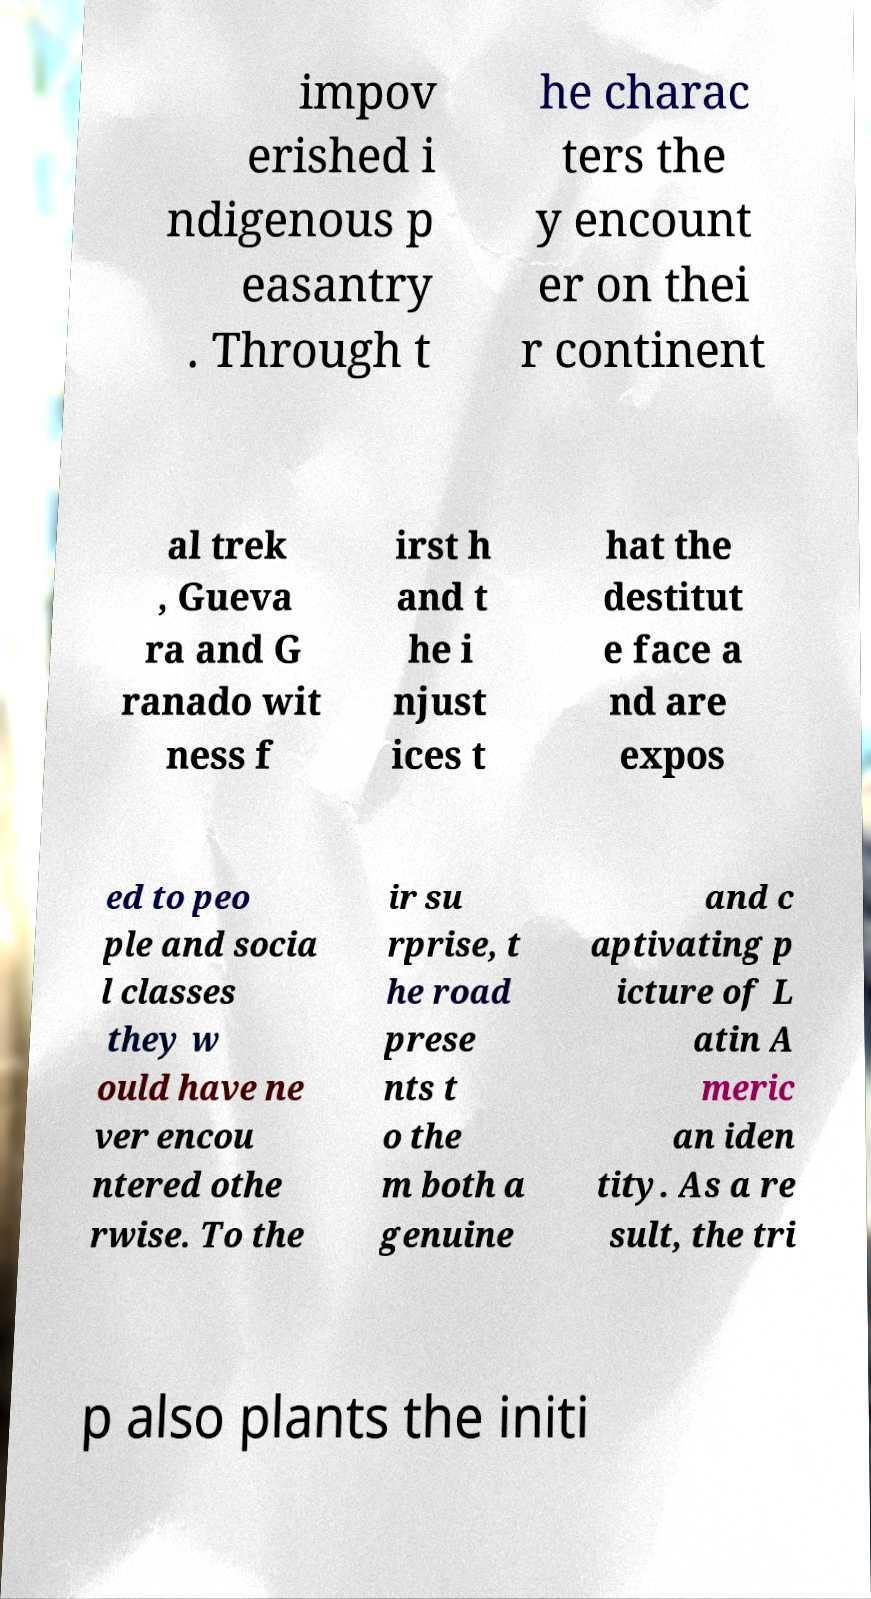I need the written content from this picture converted into text. Can you do that? impov erished i ndigenous p easantry . Through t he charac ters the y encount er on thei r continent al trek , Gueva ra and G ranado wit ness f irst h and t he i njust ices t hat the destitut e face a nd are expos ed to peo ple and socia l classes they w ould have ne ver encou ntered othe rwise. To the ir su rprise, t he road prese nts t o the m both a genuine and c aptivating p icture of L atin A meric an iden tity. As a re sult, the tri p also plants the initi 